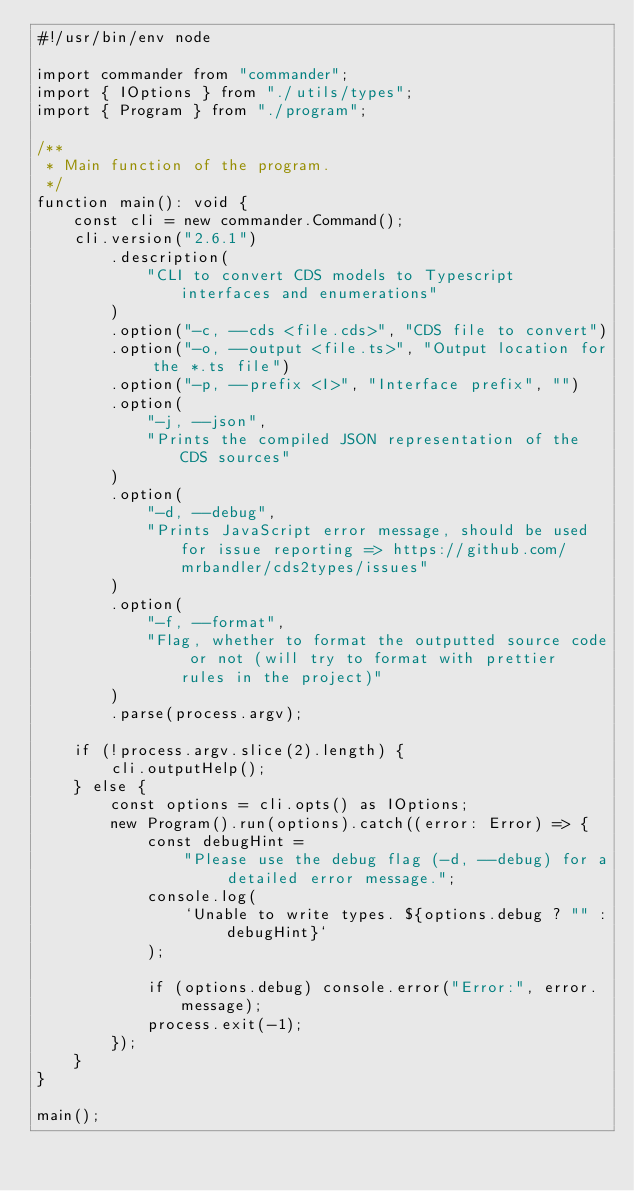<code> <loc_0><loc_0><loc_500><loc_500><_TypeScript_>#!/usr/bin/env node

import commander from "commander";
import { IOptions } from "./utils/types";
import { Program } from "./program";

/**
 * Main function of the program.
 */
function main(): void {
    const cli = new commander.Command();
    cli.version("2.6.1")
        .description(
            "CLI to convert CDS models to Typescript interfaces and enumerations"
        )
        .option("-c, --cds <file.cds>", "CDS file to convert")
        .option("-o, --output <file.ts>", "Output location for the *.ts file")
        .option("-p, --prefix <I>", "Interface prefix", "")
        .option(
            "-j, --json",
            "Prints the compiled JSON representation of the CDS sources"
        )
        .option(
            "-d, --debug",
            "Prints JavaScript error message, should be used for issue reporting => https://github.com/mrbandler/cds2types/issues"
        )
        .option(
            "-f, --format",
            "Flag, whether to format the outputted source code or not (will try to format with prettier rules in the project)"
        )
        .parse(process.argv);

    if (!process.argv.slice(2).length) {
        cli.outputHelp();
    } else {
        const options = cli.opts() as IOptions;
        new Program().run(options).catch((error: Error) => {
            const debugHint =
                "Please use the debug flag (-d, --debug) for a detailed error message.";
            console.log(
                `Unable to write types. ${options.debug ? "" : debugHint}`
            );

            if (options.debug) console.error("Error:", error.message);
            process.exit(-1);
        });
    }
}

main();
</code> 